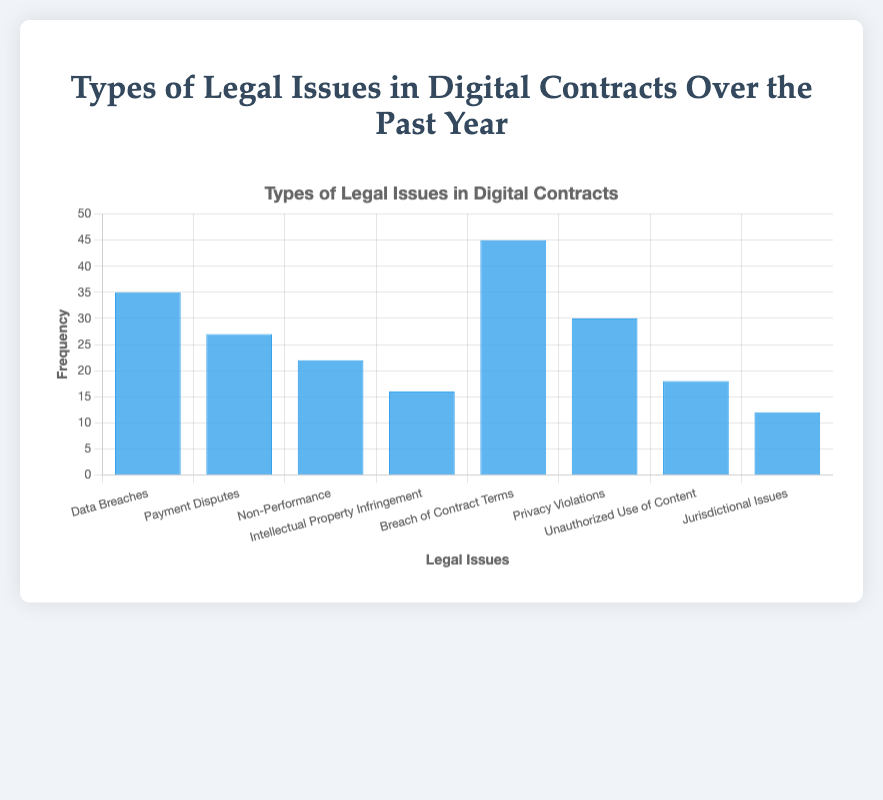Which legal issue had the highest frequency? The bar with the highest height represents the legal issue with the highest frequency. From the chart, the "Breach of Contract Terms" bar is the tallest.
Answer: Breach of Contract Terms What is the total frequency of "Data Breaches" and "Payment Disputes" combined? Add the frequencies of "Data Breaches" (35) and "Payment Disputes" (27). 35 + 27 = 62.
Answer: 62 Which legal issue had the lowest frequency? The shortest bar represents the issue with the lowest frequency. The "Jurisdictional Issues" bar is the shortest.
Answer: Jurisdictional Issues Which legal issue appears more frequently: "Privacy Violations" or "Unauthorized Use of Content"? Compare the heights of the bars for "Privacy Violations" (30) and "Unauthorized Use of Content" (18). "Privacy Violations" is taller.
Answer: Privacy Violations What's the frequency difference between "Breach of Contract Terms" and "Intellectual Property Infringement"? Subtract the frequency of "Intellectual Property Infringement" (16) from "Breach of Contract Terms" (45). 45 - 16 = 29.
Answer: 29 Is the frequency of "Non-Performance" higher or lower than the median frequency of all the issues? First, list all frequencies: 12, 16, 18, 22, 27, 30, 35, 45. The median is the average of the 4th and 5th values: (22+27)/2 = 24.5. The frequency of "Non-Performance" (22) is lower than the median.
Answer: Lower What is the average frequency of all the legal issues mentioned? Sum all frequencies: 12 + 16 + 18 + 22 + 27 + 30 + 35 + 45 = 205. There are 8 issues. Average = 205/8 = 25.625.
Answer: 25.625 How many legal issues have a frequency greater than 20? Identify and count the bars taller than 20: "Data Breaches" (35), "Payment Disputes" (27), "Non-Performance" (22), "Breach of Contract Terms" (45), "Privacy Violations" (30). There are 5 such issues.
Answer: 5 